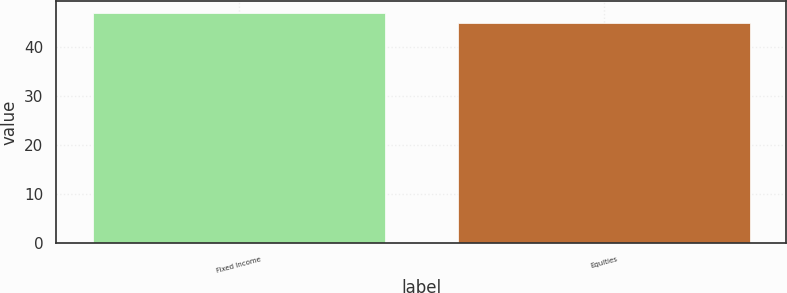Convert chart. <chart><loc_0><loc_0><loc_500><loc_500><bar_chart><fcel>Fixed Income<fcel>Equities<nl><fcel>47<fcel>45<nl></chart> 